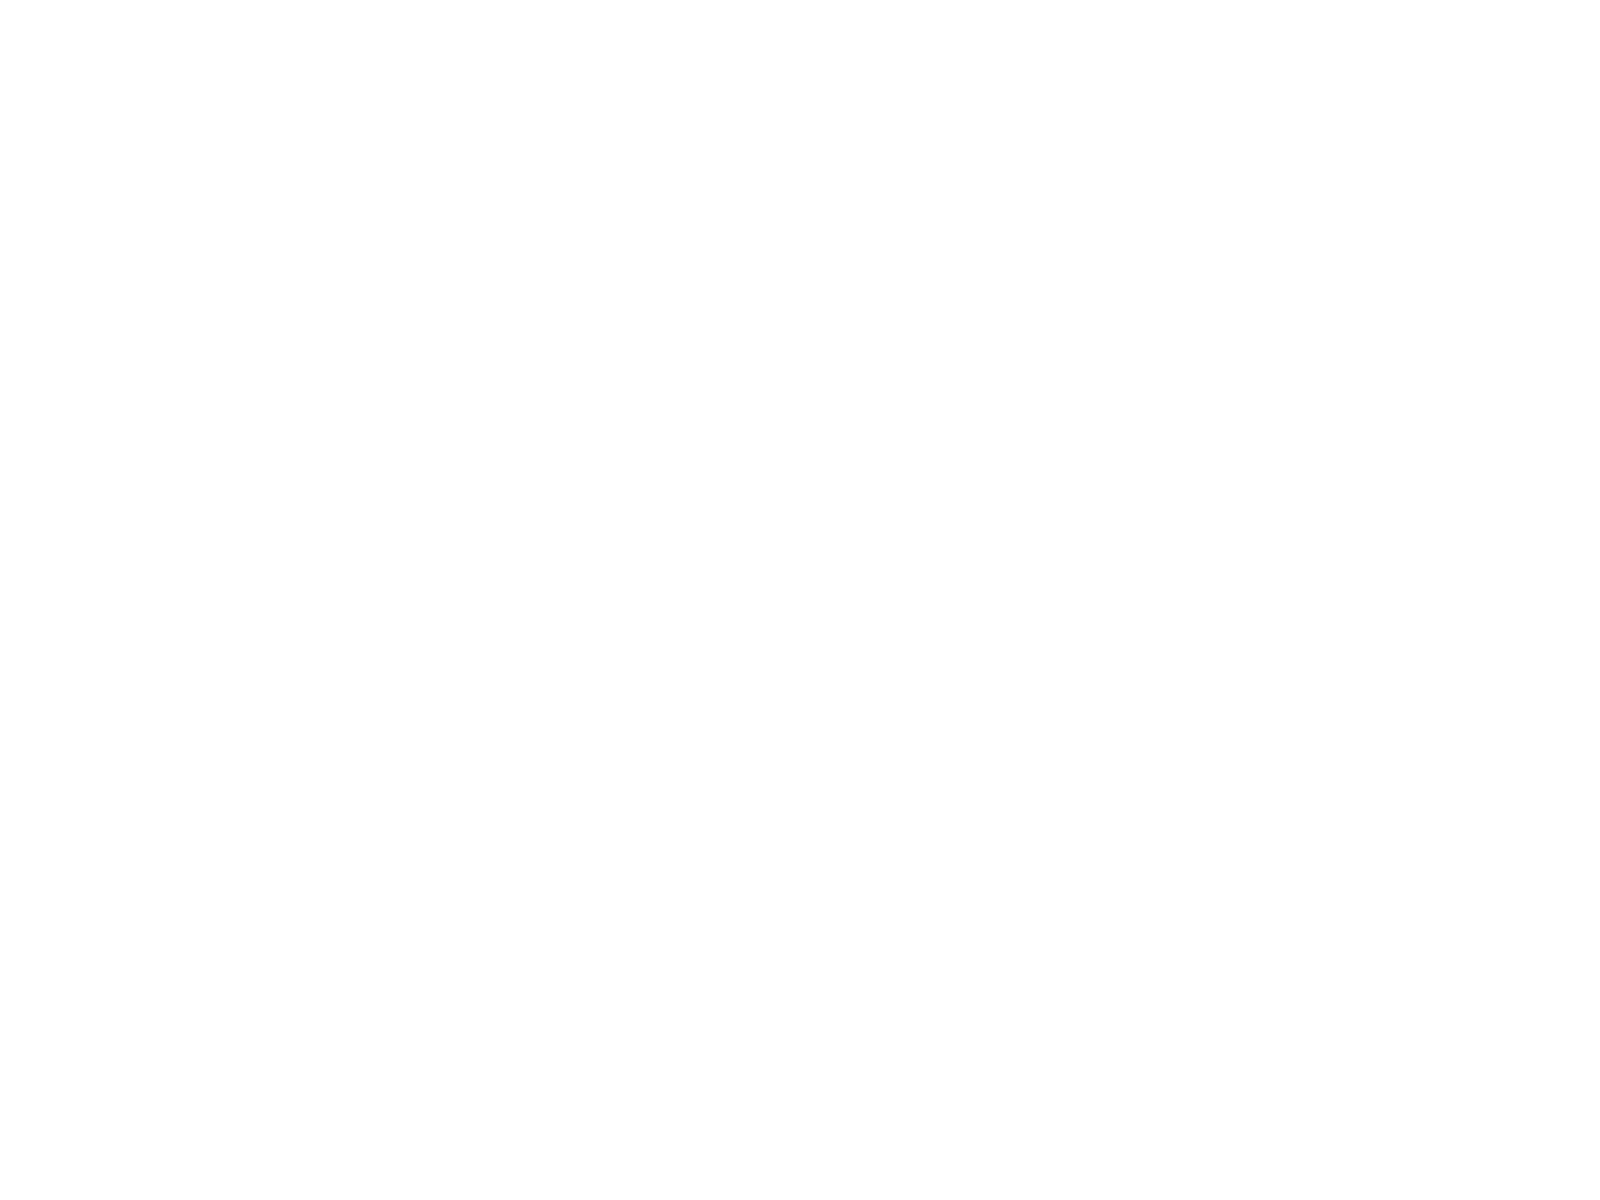<chart> <loc_0><loc_0><loc_500><loc_500><pie_chart><fcel>Fair value adjustment to cash<fcel>Reclassification adjustment<fcel>Adjustment for funded status<fcel>Amortization of pension and<fcel>Total other comprehensive<nl><fcel>1.36%<fcel>30.32%<fcel>8.45%<fcel>13.0%<fcel>46.87%<nl></chart> 